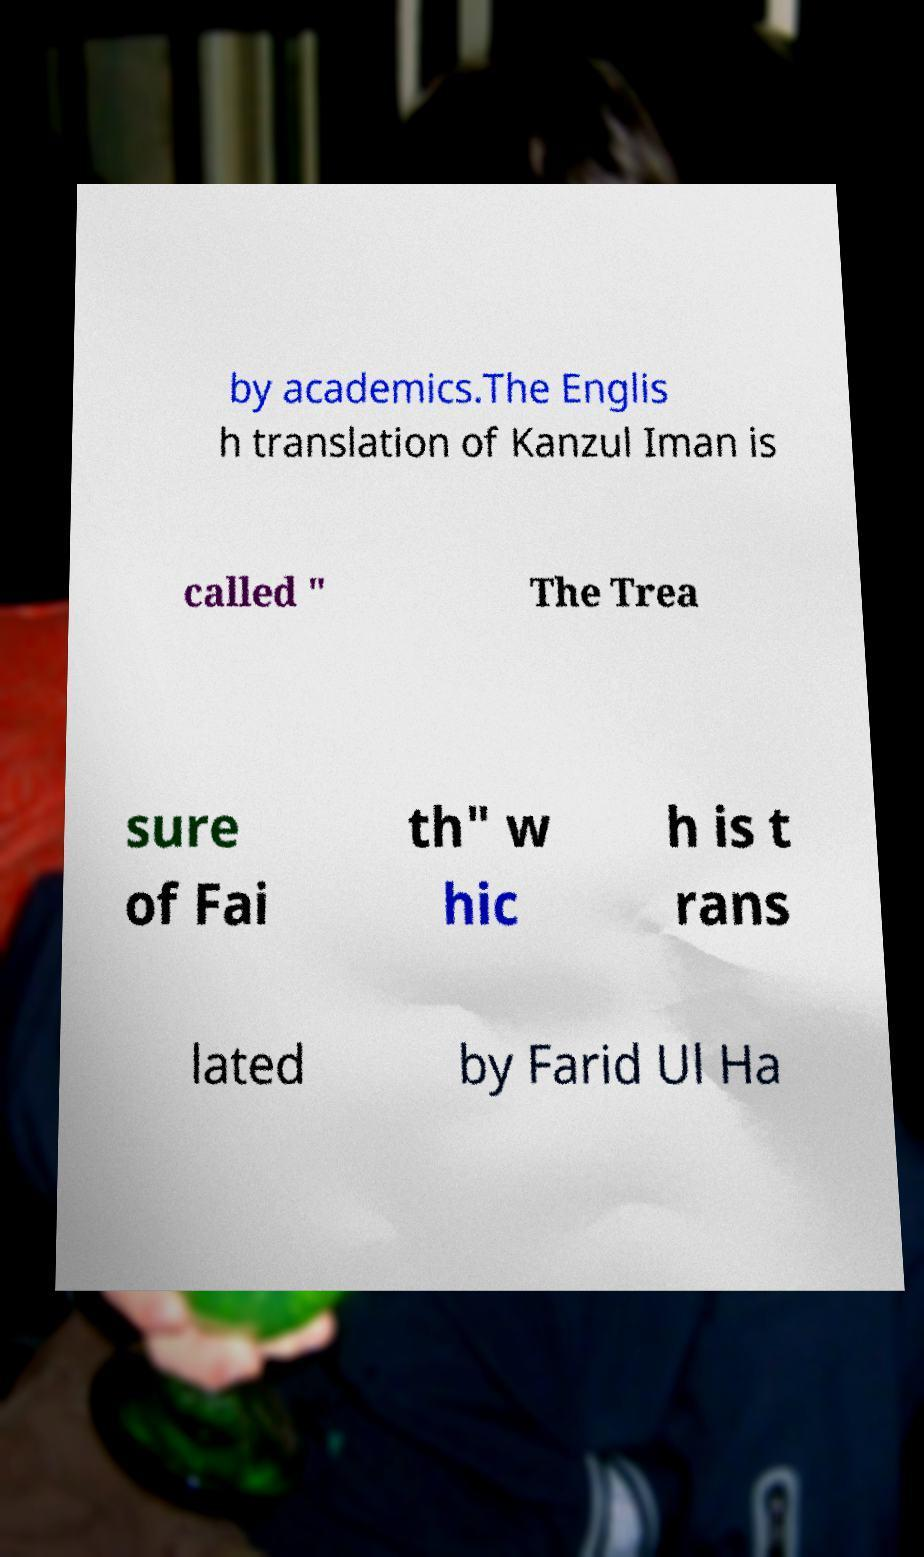What messages or text are displayed in this image? I need them in a readable, typed format. by academics.The Englis h translation of Kanzul Iman is called " The Trea sure of Fai th" w hic h is t rans lated by Farid Ul Ha 